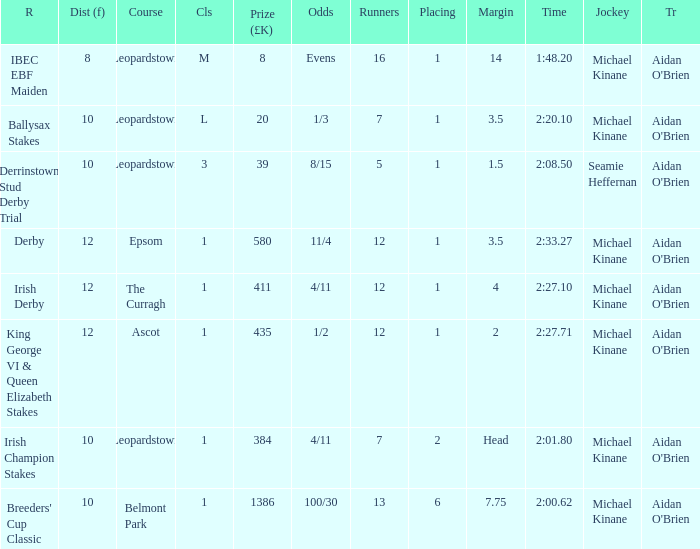Name the highest Dist (f) with Odds of 11/4 and a Placing larger than 1? None. 